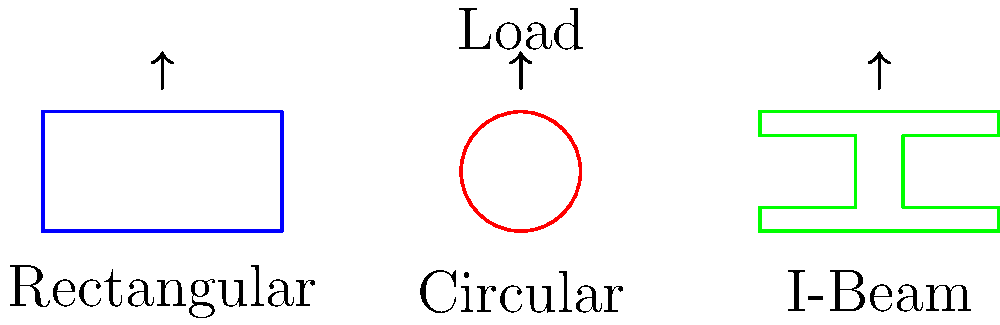As a television host discussing engineering marvels, you're presenting a segment on structural design. Which of the beam cross-sections shown above would likely have the most uniform stress distribution under a vertical load, and why is this important for structural integrity? Let's break this down step-by-step, as if we're explaining it to our television audience:

1. Stress distribution in beams depends on their cross-sectional shape.

2. The rectangular beam:
   - Has sharp corners which can concentrate stress.
   - Stress is highest at the top and bottom edges, and lowest at the neutral axis.

3. The circular beam:
   - Has no sharp corners, allowing for smoother stress flow.
   - Stress is distributed more evenly throughout the cross-section.
   - The symmetry of the circle helps in uniform stress distribution.

4. The I-beam:
   - Concentrates material at the top and bottom flanges, where bending stresses are highest.
   - The web (vertical part) mainly resists shear forces.
   - While efficient, it doesn't distribute stress as uniformly as the circular section.

5. Importance of uniform stress distribution:
   - Reduces the likelihood of stress concentrations that could lead to failure.
   - Allows for more predictable behavior under load.
   - Can potentially increase the overall strength and lifespan of the structure.

6. The circular cross-section provides the most uniform stress distribution because:
   - It has no sharp corners or edges.
   - Its symmetry allows stress to flow evenly in all directions.
   - Under torsion (twisting), it also performs better than the other shapes.

Therefore, the circular cross-section would likely have the most uniform stress distribution. This uniformity is crucial for structural integrity as it minimizes weak points and allows the material to be used most efficiently.
Answer: Circular cross-section; uniform stress distribution enhances structural integrity by minimizing weak points. 